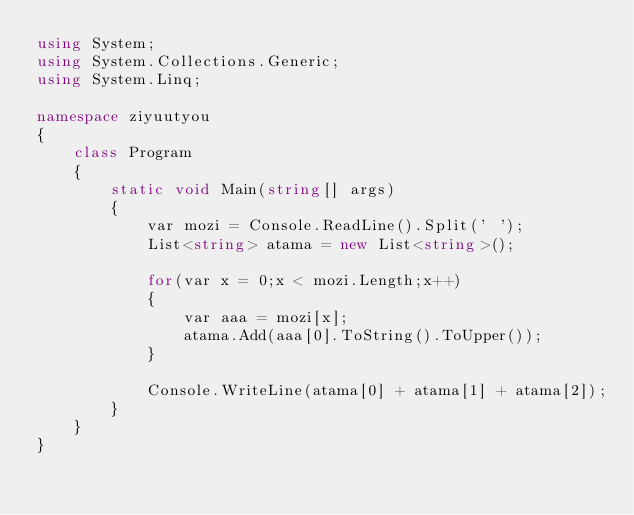Convert code to text. <code><loc_0><loc_0><loc_500><loc_500><_C#_>using System;
using System.Collections.Generic;
using System.Linq;

namespace ziyuutyou
{
    class Program
    {
        static void Main(string[] args)
        {
            var mozi = Console.ReadLine().Split(' ');
            List<string> atama = new List<string>();

            for(var x = 0;x < mozi.Length;x++)
            {
                var aaa = mozi[x];
                atama.Add(aaa[0].ToString().ToUpper());
            }

            Console.WriteLine(atama[0] + atama[1] + atama[2]);
        }
    }
}
</code> 